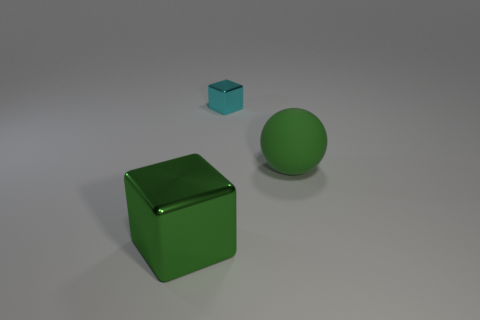Add 1 big blocks. How many objects exist? 4 Subtract all spheres. How many objects are left? 2 Add 1 tiny purple metal objects. How many tiny purple metal objects exist? 1 Subtract 0 yellow cylinders. How many objects are left? 3 Subtract all tiny yellow shiny balls. Subtract all green spheres. How many objects are left? 2 Add 1 things. How many things are left? 4 